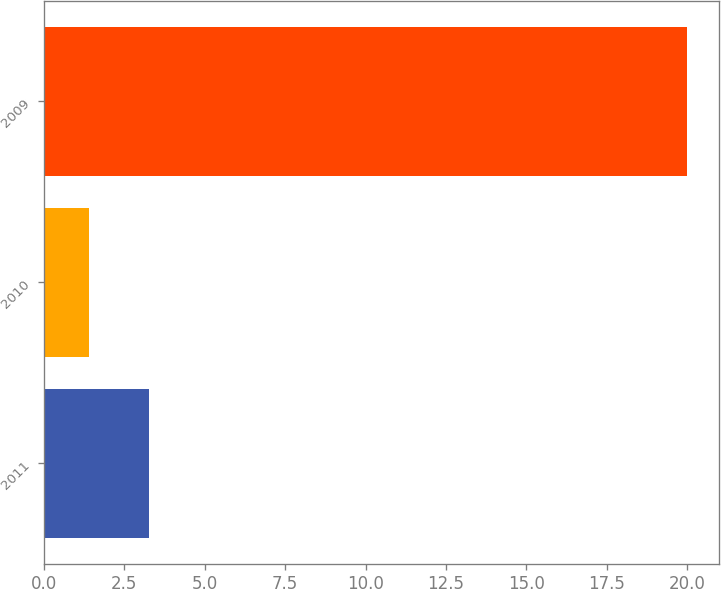Convert chart to OTSL. <chart><loc_0><loc_0><loc_500><loc_500><bar_chart><fcel>2011<fcel>2010<fcel>2009<nl><fcel>3.26<fcel>1.4<fcel>20<nl></chart> 